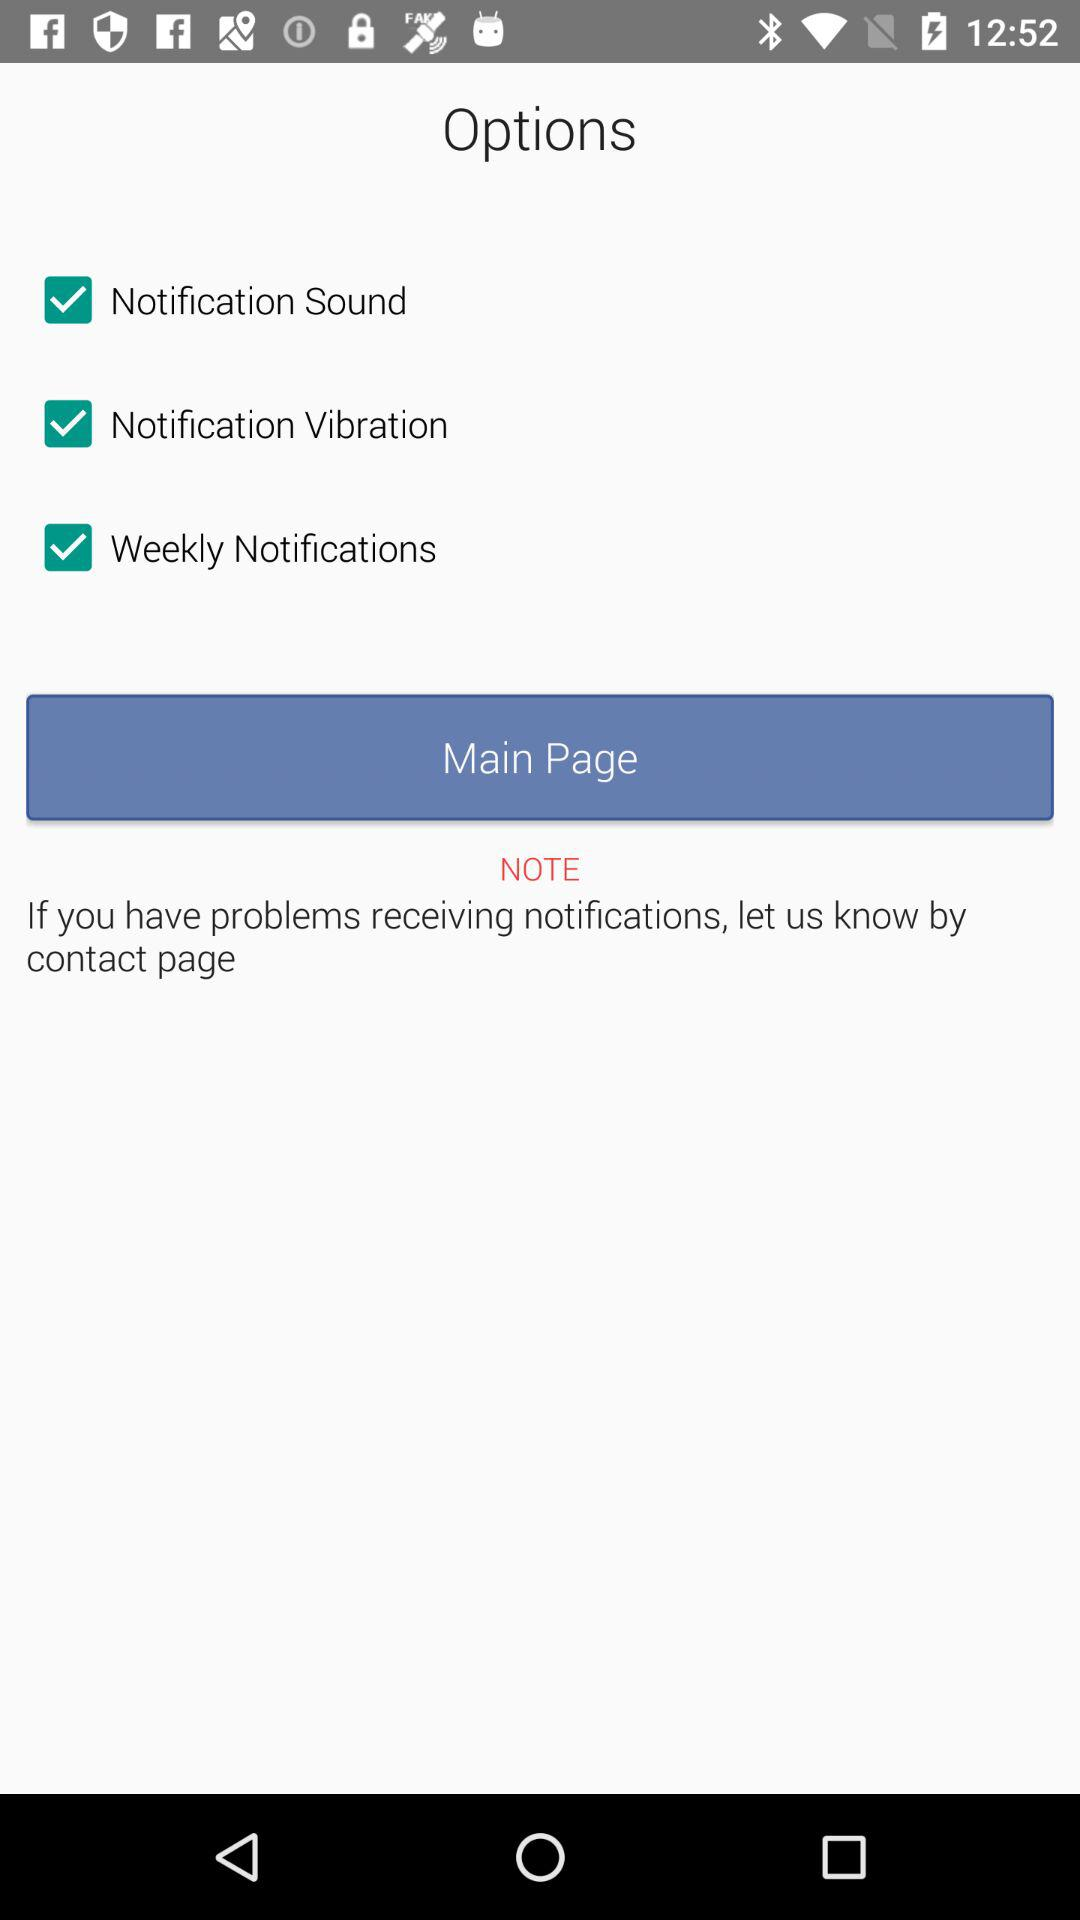What is the status of "Notification Sound"? The status of "Notification Sound" is "on". 